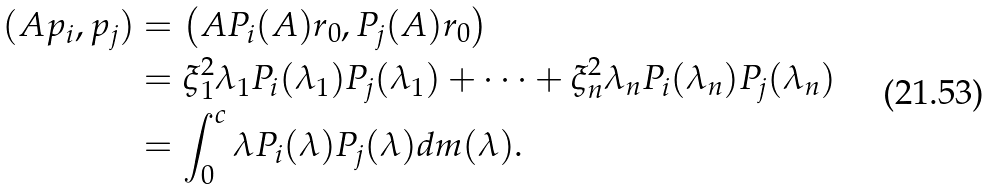Convert formula to latex. <formula><loc_0><loc_0><loc_500><loc_500>( A p _ { i } , p _ { j } ) & = \left ( A P _ { i } ( A ) r _ { 0 } , P _ { j } ( A ) r _ { 0 } \right ) \\ & = \xi _ { 1 } ^ { 2 } \lambda _ { 1 } P _ { i } ( \lambda _ { 1 } ) P _ { j } ( \lambda _ { 1 } ) + \dots + \xi _ { n } ^ { 2 } \lambda _ { n } P _ { i } ( \lambda _ { n } ) P _ { j } ( \lambda _ { n } ) \\ & = \int _ { 0 } ^ { c } \lambda P _ { i } ( \lambda ) P _ { j } ( \lambda ) d m ( \lambda ) .</formula> 